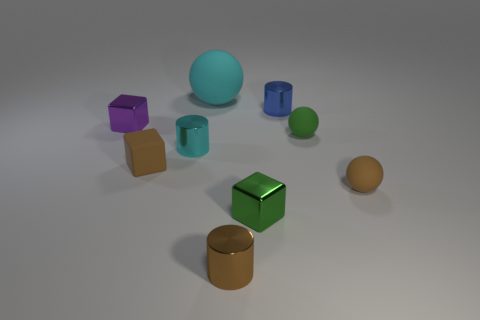Is there anything else that has the same size as the cyan matte object?
Your answer should be very brief. No. There is a sphere behind the small blue thing; how big is it?
Offer a very short reply. Large. What number of green things are shiny cubes or small rubber cubes?
Your answer should be very brief. 1. Are there any rubber objects that have the same size as the cyan shiny cylinder?
Keep it short and to the point. Yes. There is a blue cylinder that is the same size as the brown matte block; what is its material?
Offer a very short reply. Metal. There is a green matte sphere behind the small cyan object; is it the same size as the purple object that is on the left side of the tiny brown rubber sphere?
Provide a succinct answer. Yes. What number of things are shiny blocks or metal objects in front of the small purple shiny object?
Your answer should be very brief. 4. Is there another matte thing that has the same shape as the blue thing?
Keep it short and to the point. No. How big is the cylinder that is to the right of the cube that is in front of the small brown ball?
Provide a succinct answer. Small. What number of shiny things are tiny purple cubes or small brown blocks?
Your answer should be very brief. 1. 